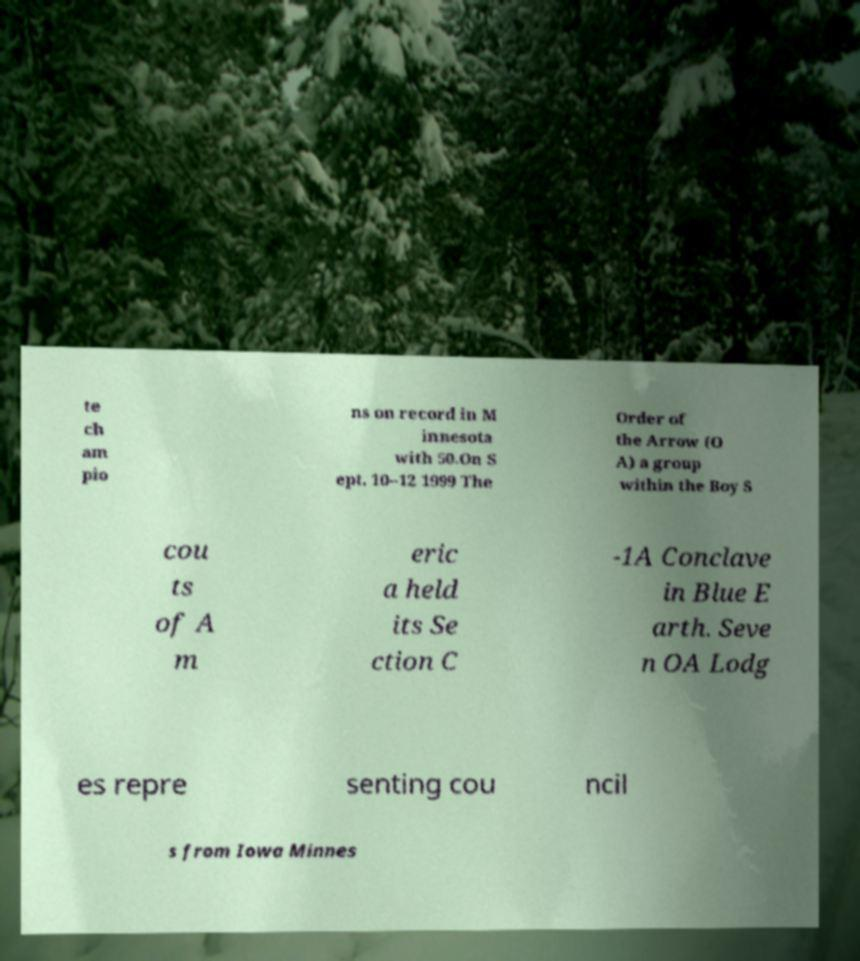I need the written content from this picture converted into text. Can you do that? te ch am pio ns on record in M innesota with 50.On S ept. 10–12 1999 The Order of the Arrow (O A) a group within the Boy S cou ts of A m eric a held its Se ction C -1A Conclave in Blue E arth. Seve n OA Lodg es repre senting cou ncil s from Iowa Minnes 